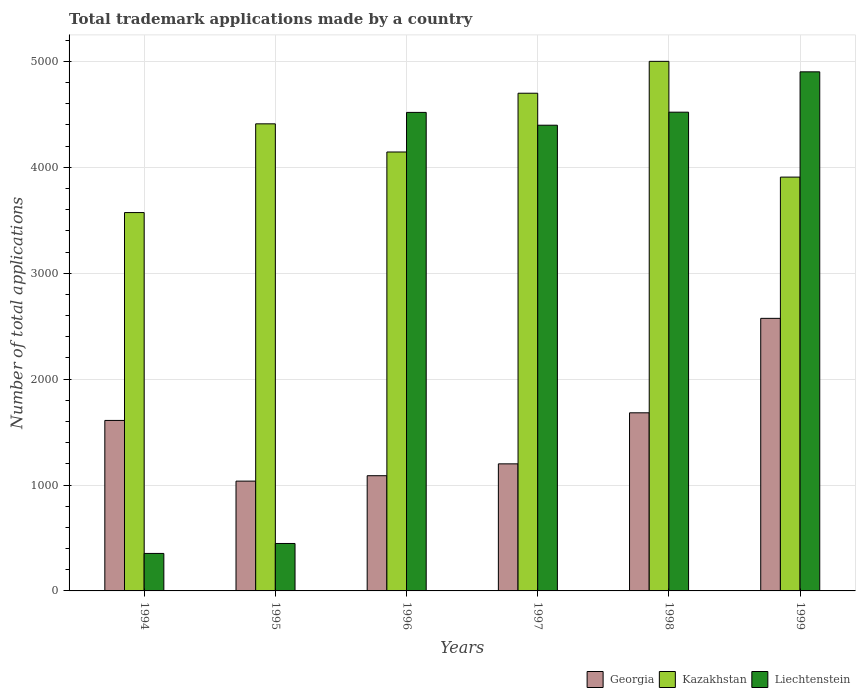How many different coloured bars are there?
Offer a terse response. 3. What is the label of the 5th group of bars from the left?
Make the answer very short. 1998. In how many cases, is the number of bars for a given year not equal to the number of legend labels?
Make the answer very short. 0. What is the number of applications made by in Kazakhstan in 1999?
Your answer should be very brief. 3908. Across all years, what is the maximum number of applications made by in Kazakhstan?
Give a very brief answer. 5001. Across all years, what is the minimum number of applications made by in Kazakhstan?
Provide a short and direct response. 3573. In which year was the number of applications made by in Kazakhstan maximum?
Your response must be concise. 1998. What is the total number of applications made by in Georgia in the graph?
Provide a short and direct response. 9191. What is the difference between the number of applications made by in Georgia in 1998 and that in 1999?
Ensure brevity in your answer.  -892. What is the difference between the number of applications made by in Georgia in 1997 and the number of applications made by in Liechtenstein in 1995?
Make the answer very short. 752. What is the average number of applications made by in Georgia per year?
Provide a short and direct response. 1531.83. In the year 1994, what is the difference between the number of applications made by in Liechtenstein and number of applications made by in Kazakhstan?
Provide a short and direct response. -3219. In how many years, is the number of applications made by in Georgia greater than 4800?
Ensure brevity in your answer.  0. What is the ratio of the number of applications made by in Georgia in 1996 to that in 1998?
Make the answer very short. 0.65. What is the difference between the highest and the second highest number of applications made by in Liechtenstein?
Your response must be concise. 381. What is the difference between the highest and the lowest number of applications made by in Georgia?
Provide a short and direct response. 1537. In how many years, is the number of applications made by in Liechtenstein greater than the average number of applications made by in Liechtenstein taken over all years?
Give a very brief answer. 4. Is the sum of the number of applications made by in Kazakhstan in 1995 and 1999 greater than the maximum number of applications made by in Liechtenstein across all years?
Make the answer very short. Yes. What does the 3rd bar from the left in 1997 represents?
Your response must be concise. Liechtenstein. What does the 3rd bar from the right in 1999 represents?
Ensure brevity in your answer.  Georgia. Are all the bars in the graph horizontal?
Offer a very short reply. No. How many years are there in the graph?
Provide a succinct answer. 6. What is the difference between two consecutive major ticks on the Y-axis?
Provide a succinct answer. 1000. Does the graph contain any zero values?
Keep it short and to the point. No. Does the graph contain grids?
Give a very brief answer. Yes. How are the legend labels stacked?
Make the answer very short. Horizontal. What is the title of the graph?
Offer a terse response. Total trademark applications made by a country. Does "Panama" appear as one of the legend labels in the graph?
Your answer should be compact. No. What is the label or title of the Y-axis?
Offer a terse response. Number of total applications. What is the Number of total applications of Georgia in 1994?
Keep it short and to the point. 1610. What is the Number of total applications in Kazakhstan in 1994?
Make the answer very short. 3573. What is the Number of total applications of Liechtenstein in 1994?
Make the answer very short. 354. What is the Number of total applications of Georgia in 1995?
Offer a terse response. 1037. What is the Number of total applications in Kazakhstan in 1995?
Give a very brief answer. 4411. What is the Number of total applications of Liechtenstein in 1995?
Offer a very short reply. 448. What is the Number of total applications in Georgia in 1996?
Provide a short and direct response. 1088. What is the Number of total applications in Kazakhstan in 1996?
Provide a short and direct response. 4145. What is the Number of total applications in Liechtenstein in 1996?
Give a very brief answer. 4519. What is the Number of total applications of Georgia in 1997?
Offer a terse response. 1200. What is the Number of total applications in Kazakhstan in 1997?
Keep it short and to the point. 4700. What is the Number of total applications in Liechtenstein in 1997?
Make the answer very short. 4398. What is the Number of total applications of Georgia in 1998?
Your response must be concise. 1682. What is the Number of total applications in Kazakhstan in 1998?
Provide a succinct answer. 5001. What is the Number of total applications of Liechtenstein in 1998?
Offer a terse response. 4521. What is the Number of total applications of Georgia in 1999?
Make the answer very short. 2574. What is the Number of total applications in Kazakhstan in 1999?
Offer a very short reply. 3908. What is the Number of total applications of Liechtenstein in 1999?
Keep it short and to the point. 4902. Across all years, what is the maximum Number of total applications in Georgia?
Offer a very short reply. 2574. Across all years, what is the maximum Number of total applications in Kazakhstan?
Your response must be concise. 5001. Across all years, what is the maximum Number of total applications of Liechtenstein?
Your answer should be very brief. 4902. Across all years, what is the minimum Number of total applications of Georgia?
Make the answer very short. 1037. Across all years, what is the minimum Number of total applications in Kazakhstan?
Your answer should be compact. 3573. Across all years, what is the minimum Number of total applications of Liechtenstein?
Offer a very short reply. 354. What is the total Number of total applications of Georgia in the graph?
Make the answer very short. 9191. What is the total Number of total applications of Kazakhstan in the graph?
Your response must be concise. 2.57e+04. What is the total Number of total applications of Liechtenstein in the graph?
Your response must be concise. 1.91e+04. What is the difference between the Number of total applications of Georgia in 1994 and that in 1995?
Ensure brevity in your answer.  573. What is the difference between the Number of total applications in Kazakhstan in 1994 and that in 1995?
Provide a short and direct response. -838. What is the difference between the Number of total applications in Liechtenstein in 1994 and that in 1995?
Keep it short and to the point. -94. What is the difference between the Number of total applications in Georgia in 1994 and that in 1996?
Make the answer very short. 522. What is the difference between the Number of total applications in Kazakhstan in 1994 and that in 1996?
Offer a very short reply. -572. What is the difference between the Number of total applications in Liechtenstein in 1994 and that in 1996?
Make the answer very short. -4165. What is the difference between the Number of total applications in Georgia in 1994 and that in 1997?
Keep it short and to the point. 410. What is the difference between the Number of total applications in Kazakhstan in 1994 and that in 1997?
Ensure brevity in your answer.  -1127. What is the difference between the Number of total applications of Liechtenstein in 1994 and that in 1997?
Provide a succinct answer. -4044. What is the difference between the Number of total applications of Georgia in 1994 and that in 1998?
Keep it short and to the point. -72. What is the difference between the Number of total applications in Kazakhstan in 1994 and that in 1998?
Offer a very short reply. -1428. What is the difference between the Number of total applications of Liechtenstein in 1994 and that in 1998?
Provide a short and direct response. -4167. What is the difference between the Number of total applications of Georgia in 1994 and that in 1999?
Provide a succinct answer. -964. What is the difference between the Number of total applications in Kazakhstan in 1994 and that in 1999?
Provide a succinct answer. -335. What is the difference between the Number of total applications of Liechtenstein in 1994 and that in 1999?
Offer a terse response. -4548. What is the difference between the Number of total applications in Georgia in 1995 and that in 1996?
Keep it short and to the point. -51. What is the difference between the Number of total applications of Kazakhstan in 1995 and that in 1996?
Your response must be concise. 266. What is the difference between the Number of total applications in Liechtenstein in 1995 and that in 1996?
Provide a short and direct response. -4071. What is the difference between the Number of total applications in Georgia in 1995 and that in 1997?
Offer a terse response. -163. What is the difference between the Number of total applications of Kazakhstan in 1995 and that in 1997?
Your response must be concise. -289. What is the difference between the Number of total applications in Liechtenstein in 1995 and that in 1997?
Make the answer very short. -3950. What is the difference between the Number of total applications of Georgia in 1995 and that in 1998?
Give a very brief answer. -645. What is the difference between the Number of total applications in Kazakhstan in 1995 and that in 1998?
Your answer should be very brief. -590. What is the difference between the Number of total applications in Liechtenstein in 1995 and that in 1998?
Your response must be concise. -4073. What is the difference between the Number of total applications in Georgia in 1995 and that in 1999?
Offer a very short reply. -1537. What is the difference between the Number of total applications in Kazakhstan in 1995 and that in 1999?
Keep it short and to the point. 503. What is the difference between the Number of total applications of Liechtenstein in 1995 and that in 1999?
Provide a succinct answer. -4454. What is the difference between the Number of total applications of Georgia in 1996 and that in 1997?
Your response must be concise. -112. What is the difference between the Number of total applications in Kazakhstan in 1996 and that in 1997?
Your answer should be compact. -555. What is the difference between the Number of total applications of Liechtenstein in 1996 and that in 1997?
Keep it short and to the point. 121. What is the difference between the Number of total applications of Georgia in 1996 and that in 1998?
Provide a short and direct response. -594. What is the difference between the Number of total applications of Kazakhstan in 1996 and that in 1998?
Provide a short and direct response. -856. What is the difference between the Number of total applications of Liechtenstein in 1996 and that in 1998?
Offer a very short reply. -2. What is the difference between the Number of total applications in Georgia in 1996 and that in 1999?
Your answer should be compact. -1486. What is the difference between the Number of total applications in Kazakhstan in 1996 and that in 1999?
Your response must be concise. 237. What is the difference between the Number of total applications of Liechtenstein in 1996 and that in 1999?
Make the answer very short. -383. What is the difference between the Number of total applications in Georgia in 1997 and that in 1998?
Offer a terse response. -482. What is the difference between the Number of total applications in Kazakhstan in 1997 and that in 1998?
Give a very brief answer. -301. What is the difference between the Number of total applications in Liechtenstein in 1997 and that in 1998?
Offer a terse response. -123. What is the difference between the Number of total applications of Georgia in 1997 and that in 1999?
Ensure brevity in your answer.  -1374. What is the difference between the Number of total applications of Kazakhstan in 1997 and that in 1999?
Your answer should be compact. 792. What is the difference between the Number of total applications in Liechtenstein in 1997 and that in 1999?
Ensure brevity in your answer.  -504. What is the difference between the Number of total applications of Georgia in 1998 and that in 1999?
Offer a very short reply. -892. What is the difference between the Number of total applications of Kazakhstan in 1998 and that in 1999?
Ensure brevity in your answer.  1093. What is the difference between the Number of total applications in Liechtenstein in 1998 and that in 1999?
Provide a succinct answer. -381. What is the difference between the Number of total applications of Georgia in 1994 and the Number of total applications of Kazakhstan in 1995?
Provide a short and direct response. -2801. What is the difference between the Number of total applications of Georgia in 1994 and the Number of total applications of Liechtenstein in 1995?
Your response must be concise. 1162. What is the difference between the Number of total applications of Kazakhstan in 1994 and the Number of total applications of Liechtenstein in 1995?
Provide a succinct answer. 3125. What is the difference between the Number of total applications in Georgia in 1994 and the Number of total applications in Kazakhstan in 1996?
Provide a short and direct response. -2535. What is the difference between the Number of total applications of Georgia in 1994 and the Number of total applications of Liechtenstein in 1996?
Your answer should be compact. -2909. What is the difference between the Number of total applications in Kazakhstan in 1994 and the Number of total applications in Liechtenstein in 1996?
Give a very brief answer. -946. What is the difference between the Number of total applications in Georgia in 1994 and the Number of total applications in Kazakhstan in 1997?
Provide a short and direct response. -3090. What is the difference between the Number of total applications in Georgia in 1994 and the Number of total applications in Liechtenstein in 1997?
Provide a short and direct response. -2788. What is the difference between the Number of total applications in Kazakhstan in 1994 and the Number of total applications in Liechtenstein in 1997?
Provide a succinct answer. -825. What is the difference between the Number of total applications in Georgia in 1994 and the Number of total applications in Kazakhstan in 1998?
Keep it short and to the point. -3391. What is the difference between the Number of total applications in Georgia in 1994 and the Number of total applications in Liechtenstein in 1998?
Provide a succinct answer. -2911. What is the difference between the Number of total applications in Kazakhstan in 1994 and the Number of total applications in Liechtenstein in 1998?
Offer a very short reply. -948. What is the difference between the Number of total applications in Georgia in 1994 and the Number of total applications in Kazakhstan in 1999?
Your answer should be compact. -2298. What is the difference between the Number of total applications of Georgia in 1994 and the Number of total applications of Liechtenstein in 1999?
Keep it short and to the point. -3292. What is the difference between the Number of total applications of Kazakhstan in 1994 and the Number of total applications of Liechtenstein in 1999?
Offer a very short reply. -1329. What is the difference between the Number of total applications in Georgia in 1995 and the Number of total applications in Kazakhstan in 1996?
Ensure brevity in your answer.  -3108. What is the difference between the Number of total applications in Georgia in 1995 and the Number of total applications in Liechtenstein in 1996?
Ensure brevity in your answer.  -3482. What is the difference between the Number of total applications of Kazakhstan in 1995 and the Number of total applications of Liechtenstein in 1996?
Your answer should be compact. -108. What is the difference between the Number of total applications in Georgia in 1995 and the Number of total applications in Kazakhstan in 1997?
Provide a succinct answer. -3663. What is the difference between the Number of total applications of Georgia in 1995 and the Number of total applications of Liechtenstein in 1997?
Ensure brevity in your answer.  -3361. What is the difference between the Number of total applications in Kazakhstan in 1995 and the Number of total applications in Liechtenstein in 1997?
Provide a succinct answer. 13. What is the difference between the Number of total applications in Georgia in 1995 and the Number of total applications in Kazakhstan in 1998?
Offer a very short reply. -3964. What is the difference between the Number of total applications of Georgia in 1995 and the Number of total applications of Liechtenstein in 1998?
Ensure brevity in your answer.  -3484. What is the difference between the Number of total applications of Kazakhstan in 1995 and the Number of total applications of Liechtenstein in 1998?
Offer a very short reply. -110. What is the difference between the Number of total applications of Georgia in 1995 and the Number of total applications of Kazakhstan in 1999?
Offer a very short reply. -2871. What is the difference between the Number of total applications in Georgia in 1995 and the Number of total applications in Liechtenstein in 1999?
Offer a terse response. -3865. What is the difference between the Number of total applications of Kazakhstan in 1995 and the Number of total applications of Liechtenstein in 1999?
Provide a succinct answer. -491. What is the difference between the Number of total applications in Georgia in 1996 and the Number of total applications in Kazakhstan in 1997?
Keep it short and to the point. -3612. What is the difference between the Number of total applications in Georgia in 1996 and the Number of total applications in Liechtenstein in 1997?
Offer a very short reply. -3310. What is the difference between the Number of total applications in Kazakhstan in 1996 and the Number of total applications in Liechtenstein in 1997?
Your answer should be compact. -253. What is the difference between the Number of total applications of Georgia in 1996 and the Number of total applications of Kazakhstan in 1998?
Your answer should be very brief. -3913. What is the difference between the Number of total applications of Georgia in 1996 and the Number of total applications of Liechtenstein in 1998?
Provide a succinct answer. -3433. What is the difference between the Number of total applications in Kazakhstan in 1996 and the Number of total applications in Liechtenstein in 1998?
Offer a very short reply. -376. What is the difference between the Number of total applications in Georgia in 1996 and the Number of total applications in Kazakhstan in 1999?
Make the answer very short. -2820. What is the difference between the Number of total applications in Georgia in 1996 and the Number of total applications in Liechtenstein in 1999?
Your answer should be compact. -3814. What is the difference between the Number of total applications of Kazakhstan in 1996 and the Number of total applications of Liechtenstein in 1999?
Make the answer very short. -757. What is the difference between the Number of total applications in Georgia in 1997 and the Number of total applications in Kazakhstan in 1998?
Keep it short and to the point. -3801. What is the difference between the Number of total applications in Georgia in 1997 and the Number of total applications in Liechtenstein in 1998?
Make the answer very short. -3321. What is the difference between the Number of total applications in Kazakhstan in 1997 and the Number of total applications in Liechtenstein in 1998?
Provide a succinct answer. 179. What is the difference between the Number of total applications in Georgia in 1997 and the Number of total applications in Kazakhstan in 1999?
Keep it short and to the point. -2708. What is the difference between the Number of total applications of Georgia in 1997 and the Number of total applications of Liechtenstein in 1999?
Provide a succinct answer. -3702. What is the difference between the Number of total applications of Kazakhstan in 1997 and the Number of total applications of Liechtenstein in 1999?
Provide a succinct answer. -202. What is the difference between the Number of total applications in Georgia in 1998 and the Number of total applications in Kazakhstan in 1999?
Your answer should be very brief. -2226. What is the difference between the Number of total applications in Georgia in 1998 and the Number of total applications in Liechtenstein in 1999?
Your response must be concise. -3220. What is the difference between the Number of total applications of Kazakhstan in 1998 and the Number of total applications of Liechtenstein in 1999?
Ensure brevity in your answer.  99. What is the average Number of total applications of Georgia per year?
Offer a very short reply. 1531.83. What is the average Number of total applications of Kazakhstan per year?
Ensure brevity in your answer.  4289.67. What is the average Number of total applications in Liechtenstein per year?
Offer a very short reply. 3190.33. In the year 1994, what is the difference between the Number of total applications of Georgia and Number of total applications of Kazakhstan?
Provide a succinct answer. -1963. In the year 1994, what is the difference between the Number of total applications in Georgia and Number of total applications in Liechtenstein?
Give a very brief answer. 1256. In the year 1994, what is the difference between the Number of total applications of Kazakhstan and Number of total applications of Liechtenstein?
Ensure brevity in your answer.  3219. In the year 1995, what is the difference between the Number of total applications in Georgia and Number of total applications in Kazakhstan?
Give a very brief answer. -3374. In the year 1995, what is the difference between the Number of total applications of Georgia and Number of total applications of Liechtenstein?
Give a very brief answer. 589. In the year 1995, what is the difference between the Number of total applications of Kazakhstan and Number of total applications of Liechtenstein?
Give a very brief answer. 3963. In the year 1996, what is the difference between the Number of total applications in Georgia and Number of total applications in Kazakhstan?
Give a very brief answer. -3057. In the year 1996, what is the difference between the Number of total applications in Georgia and Number of total applications in Liechtenstein?
Your answer should be very brief. -3431. In the year 1996, what is the difference between the Number of total applications of Kazakhstan and Number of total applications of Liechtenstein?
Give a very brief answer. -374. In the year 1997, what is the difference between the Number of total applications of Georgia and Number of total applications of Kazakhstan?
Provide a succinct answer. -3500. In the year 1997, what is the difference between the Number of total applications in Georgia and Number of total applications in Liechtenstein?
Make the answer very short. -3198. In the year 1997, what is the difference between the Number of total applications of Kazakhstan and Number of total applications of Liechtenstein?
Give a very brief answer. 302. In the year 1998, what is the difference between the Number of total applications of Georgia and Number of total applications of Kazakhstan?
Provide a succinct answer. -3319. In the year 1998, what is the difference between the Number of total applications in Georgia and Number of total applications in Liechtenstein?
Ensure brevity in your answer.  -2839. In the year 1998, what is the difference between the Number of total applications of Kazakhstan and Number of total applications of Liechtenstein?
Offer a terse response. 480. In the year 1999, what is the difference between the Number of total applications in Georgia and Number of total applications in Kazakhstan?
Offer a very short reply. -1334. In the year 1999, what is the difference between the Number of total applications in Georgia and Number of total applications in Liechtenstein?
Your response must be concise. -2328. In the year 1999, what is the difference between the Number of total applications of Kazakhstan and Number of total applications of Liechtenstein?
Ensure brevity in your answer.  -994. What is the ratio of the Number of total applications in Georgia in 1994 to that in 1995?
Provide a short and direct response. 1.55. What is the ratio of the Number of total applications of Kazakhstan in 1994 to that in 1995?
Your answer should be compact. 0.81. What is the ratio of the Number of total applications of Liechtenstein in 1994 to that in 1995?
Your answer should be compact. 0.79. What is the ratio of the Number of total applications in Georgia in 1994 to that in 1996?
Provide a short and direct response. 1.48. What is the ratio of the Number of total applications of Kazakhstan in 1994 to that in 1996?
Your answer should be very brief. 0.86. What is the ratio of the Number of total applications in Liechtenstein in 1994 to that in 1996?
Make the answer very short. 0.08. What is the ratio of the Number of total applications in Georgia in 1994 to that in 1997?
Ensure brevity in your answer.  1.34. What is the ratio of the Number of total applications in Kazakhstan in 1994 to that in 1997?
Make the answer very short. 0.76. What is the ratio of the Number of total applications of Liechtenstein in 1994 to that in 1997?
Offer a very short reply. 0.08. What is the ratio of the Number of total applications in Georgia in 1994 to that in 1998?
Your answer should be very brief. 0.96. What is the ratio of the Number of total applications in Kazakhstan in 1994 to that in 1998?
Your answer should be compact. 0.71. What is the ratio of the Number of total applications of Liechtenstein in 1994 to that in 1998?
Give a very brief answer. 0.08. What is the ratio of the Number of total applications in Georgia in 1994 to that in 1999?
Keep it short and to the point. 0.63. What is the ratio of the Number of total applications of Kazakhstan in 1994 to that in 1999?
Offer a terse response. 0.91. What is the ratio of the Number of total applications of Liechtenstein in 1994 to that in 1999?
Your response must be concise. 0.07. What is the ratio of the Number of total applications of Georgia in 1995 to that in 1996?
Your response must be concise. 0.95. What is the ratio of the Number of total applications of Kazakhstan in 1995 to that in 1996?
Give a very brief answer. 1.06. What is the ratio of the Number of total applications in Liechtenstein in 1995 to that in 1996?
Offer a very short reply. 0.1. What is the ratio of the Number of total applications of Georgia in 1995 to that in 1997?
Offer a very short reply. 0.86. What is the ratio of the Number of total applications of Kazakhstan in 1995 to that in 1997?
Offer a terse response. 0.94. What is the ratio of the Number of total applications in Liechtenstein in 1995 to that in 1997?
Keep it short and to the point. 0.1. What is the ratio of the Number of total applications in Georgia in 1995 to that in 1998?
Offer a terse response. 0.62. What is the ratio of the Number of total applications in Kazakhstan in 1995 to that in 1998?
Offer a very short reply. 0.88. What is the ratio of the Number of total applications in Liechtenstein in 1995 to that in 1998?
Offer a terse response. 0.1. What is the ratio of the Number of total applications in Georgia in 1995 to that in 1999?
Ensure brevity in your answer.  0.4. What is the ratio of the Number of total applications of Kazakhstan in 1995 to that in 1999?
Give a very brief answer. 1.13. What is the ratio of the Number of total applications in Liechtenstein in 1995 to that in 1999?
Your answer should be compact. 0.09. What is the ratio of the Number of total applications of Georgia in 1996 to that in 1997?
Offer a very short reply. 0.91. What is the ratio of the Number of total applications of Kazakhstan in 1996 to that in 1997?
Give a very brief answer. 0.88. What is the ratio of the Number of total applications in Liechtenstein in 1996 to that in 1997?
Offer a terse response. 1.03. What is the ratio of the Number of total applications in Georgia in 1996 to that in 1998?
Offer a terse response. 0.65. What is the ratio of the Number of total applications in Kazakhstan in 1996 to that in 1998?
Provide a short and direct response. 0.83. What is the ratio of the Number of total applications in Liechtenstein in 1996 to that in 1998?
Give a very brief answer. 1. What is the ratio of the Number of total applications in Georgia in 1996 to that in 1999?
Keep it short and to the point. 0.42. What is the ratio of the Number of total applications of Kazakhstan in 1996 to that in 1999?
Your answer should be very brief. 1.06. What is the ratio of the Number of total applications in Liechtenstein in 1996 to that in 1999?
Your response must be concise. 0.92. What is the ratio of the Number of total applications in Georgia in 1997 to that in 1998?
Your answer should be very brief. 0.71. What is the ratio of the Number of total applications of Kazakhstan in 1997 to that in 1998?
Ensure brevity in your answer.  0.94. What is the ratio of the Number of total applications of Liechtenstein in 1997 to that in 1998?
Make the answer very short. 0.97. What is the ratio of the Number of total applications of Georgia in 1997 to that in 1999?
Offer a terse response. 0.47. What is the ratio of the Number of total applications in Kazakhstan in 1997 to that in 1999?
Provide a succinct answer. 1.2. What is the ratio of the Number of total applications of Liechtenstein in 1997 to that in 1999?
Make the answer very short. 0.9. What is the ratio of the Number of total applications of Georgia in 1998 to that in 1999?
Provide a succinct answer. 0.65. What is the ratio of the Number of total applications of Kazakhstan in 1998 to that in 1999?
Ensure brevity in your answer.  1.28. What is the ratio of the Number of total applications in Liechtenstein in 1998 to that in 1999?
Your answer should be compact. 0.92. What is the difference between the highest and the second highest Number of total applications in Georgia?
Provide a short and direct response. 892. What is the difference between the highest and the second highest Number of total applications of Kazakhstan?
Give a very brief answer. 301. What is the difference between the highest and the second highest Number of total applications in Liechtenstein?
Make the answer very short. 381. What is the difference between the highest and the lowest Number of total applications in Georgia?
Keep it short and to the point. 1537. What is the difference between the highest and the lowest Number of total applications in Kazakhstan?
Make the answer very short. 1428. What is the difference between the highest and the lowest Number of total applications in Liechtenstein?
Your answer should be compact. 4548. 